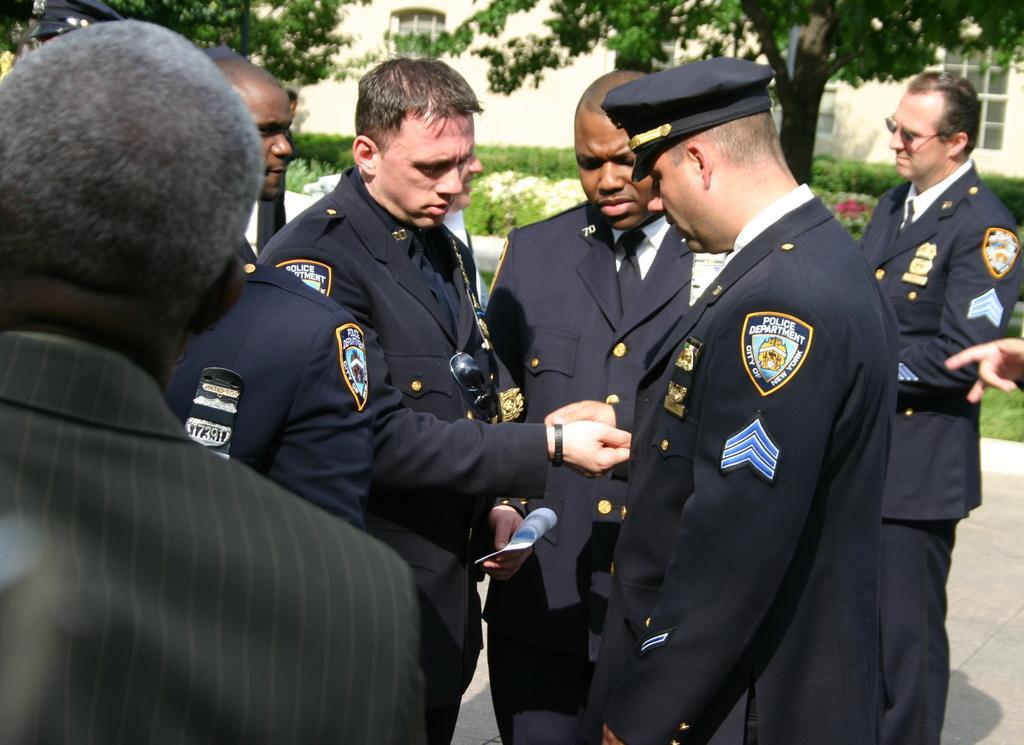In one or two sentences, can you explain what this image depicts? In this image we can see a few persons standing, among them two persons are holding the objects, in the background, we can see some plants, flowers, trees and a building. 